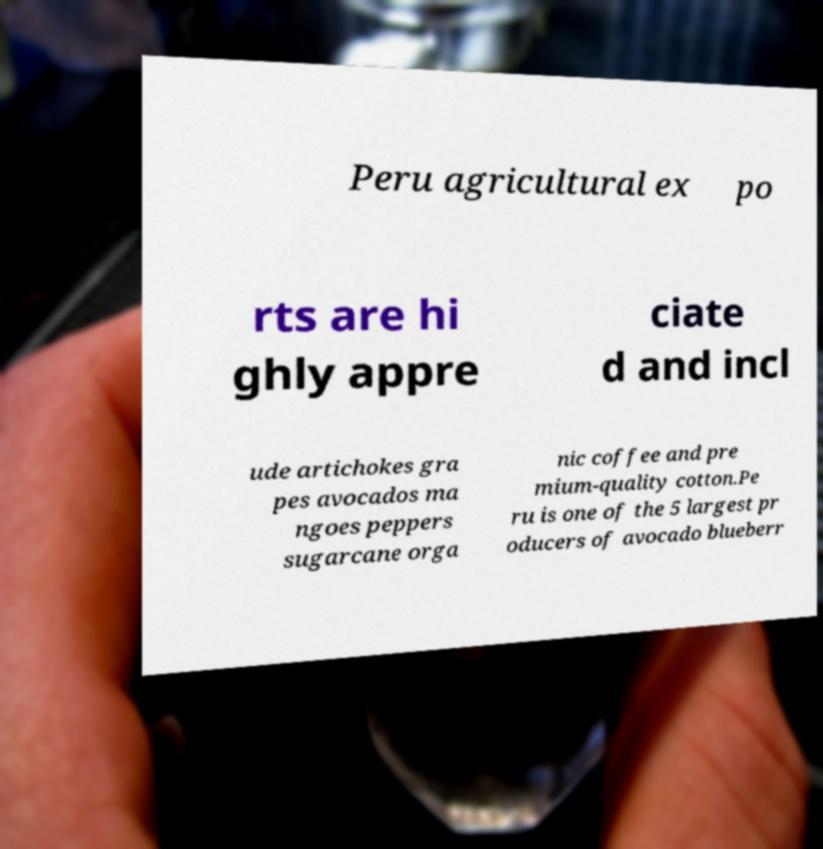Can you accurately transcribe the text from the provided image for me? Peru agricultural ex po rts are hi ghly appre ciate d and incl ude artichokes gra pes avocados ma ngoes peppers sugarcane orga nic coffee and pre mium-quality cotton.Pe ru is one of the 5 largest pr oducers of avocado blueberr 